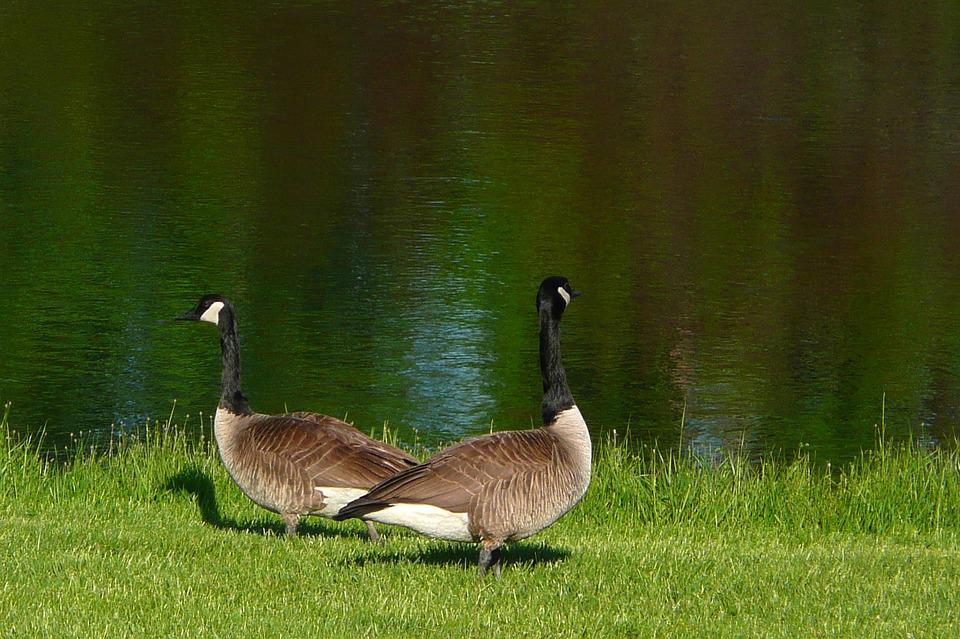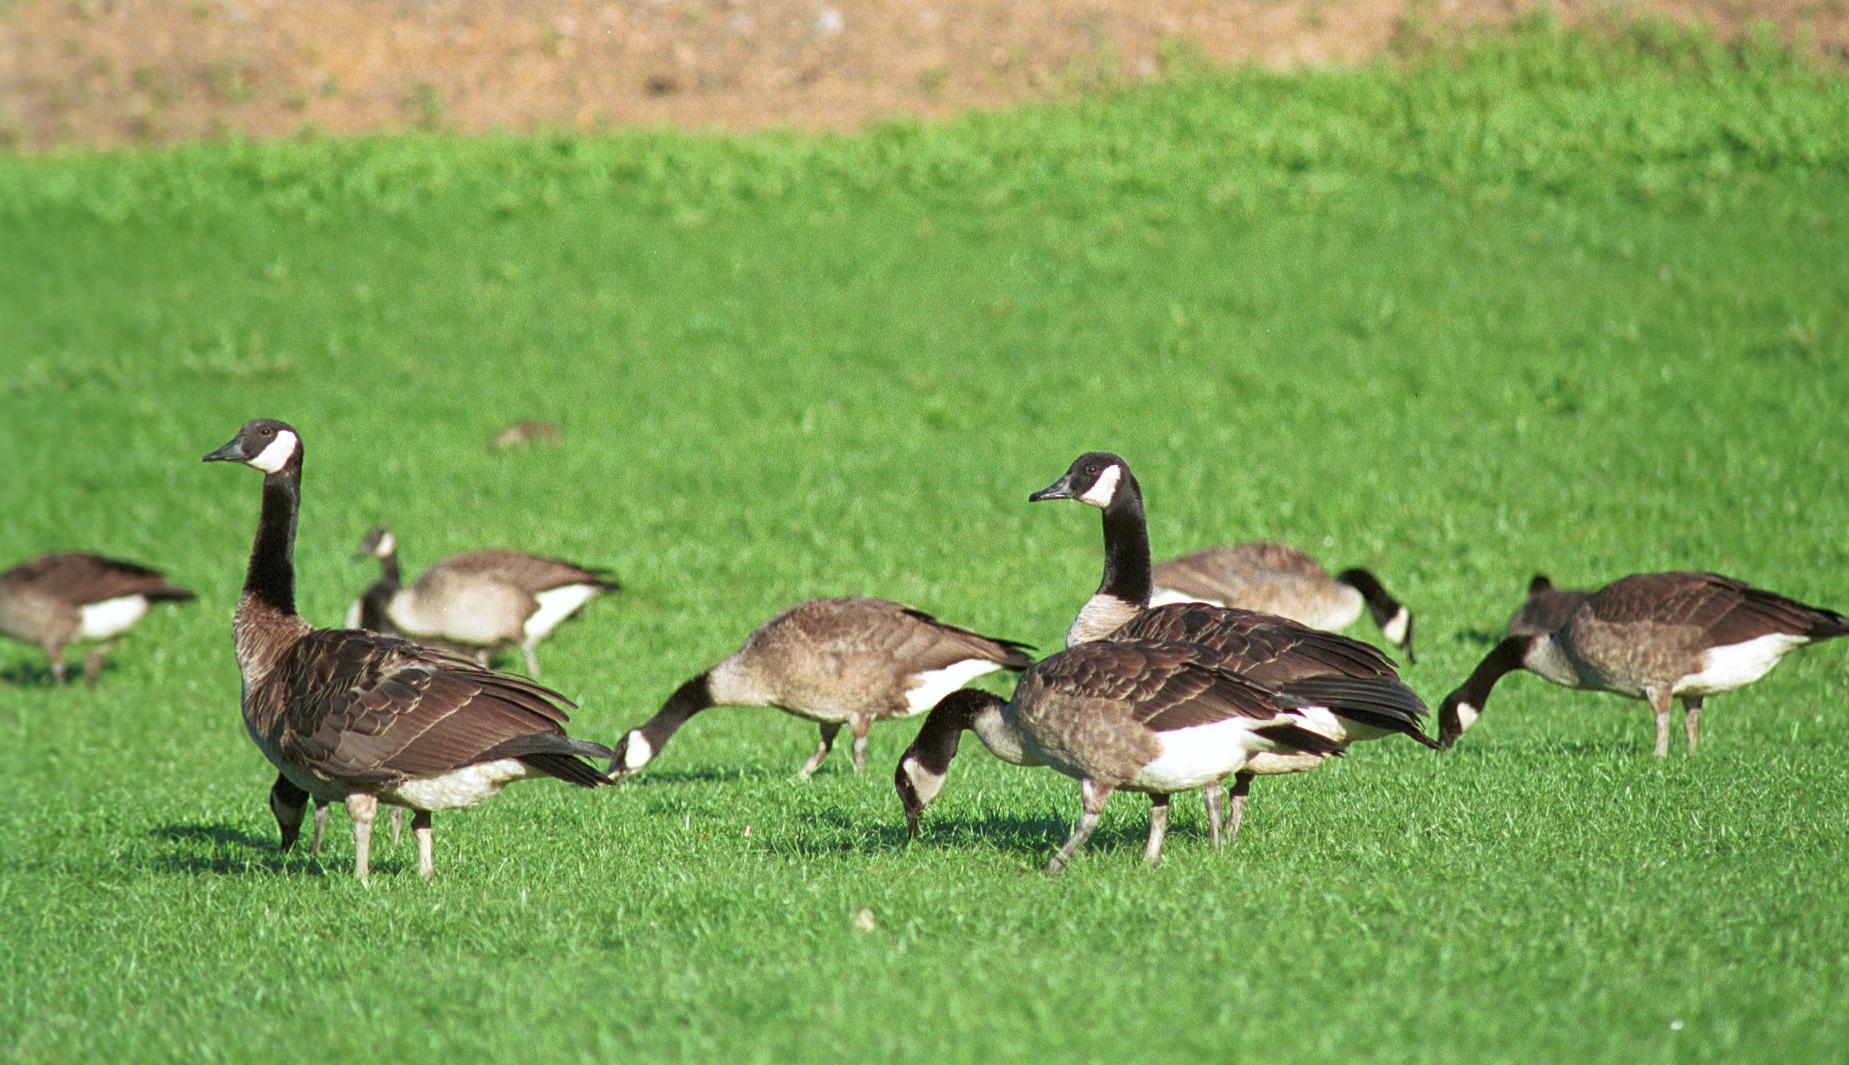The first image is the image on the left, the second image is the image on the right. Evaluate the accuracy of this statement regarding the images: "One of the images shows exactly two geese.". Is it true? Answer yes or no. Yes. The first image is the image on the left, the second image is the image on the right. Evaluate the accuracy of this statement regarding the images: "Exactly two Canada geese are in or near a body of water.". Is it true? Answer yes or no. Yes. 